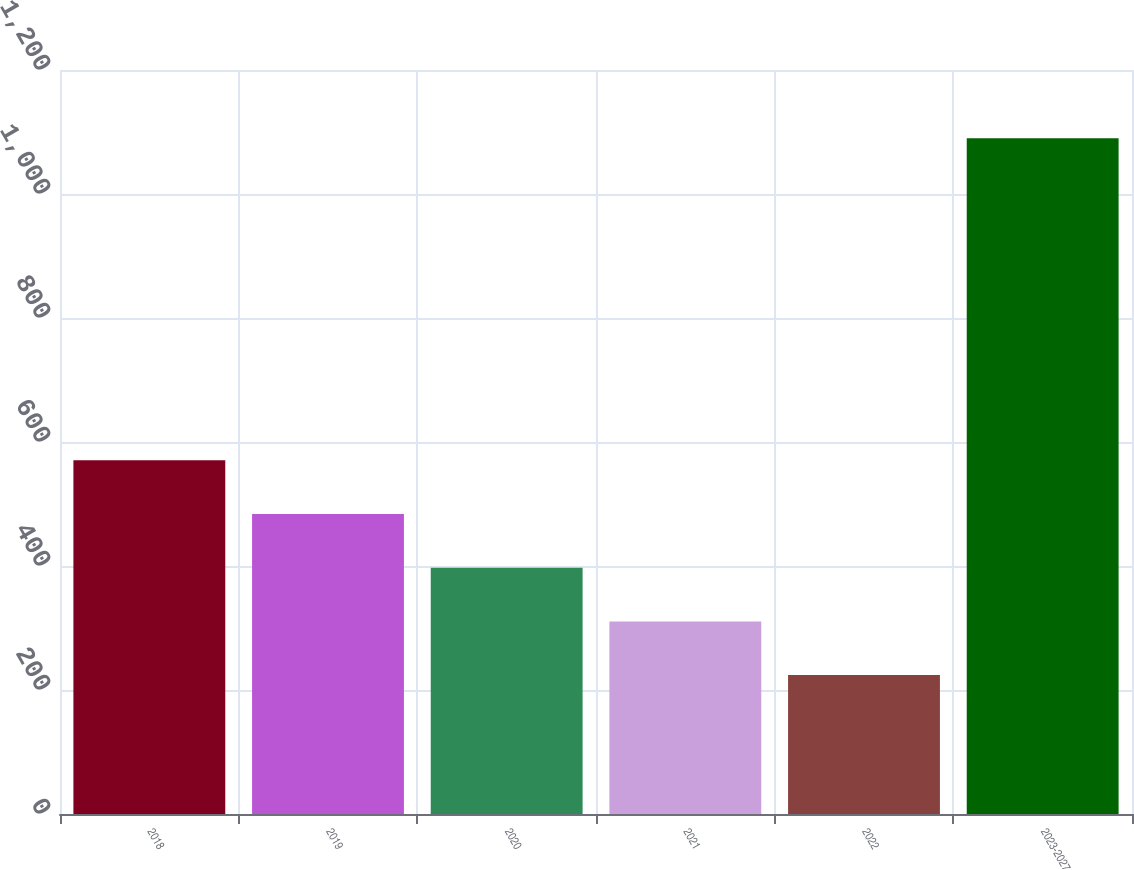Convert chart to OTSL. <chart><loc_0><loc_0><loc_500><loc_500><bar_chart><fcel>2018<fcel>2019<fcel>2020<fcel>2021<fcel>2022<fcel>2023-2027<nl><fcel>570.4<fcel>483.8<fcel>397.2<fcel>310.6<fcel>224<fcel>1090<nl></chart> 